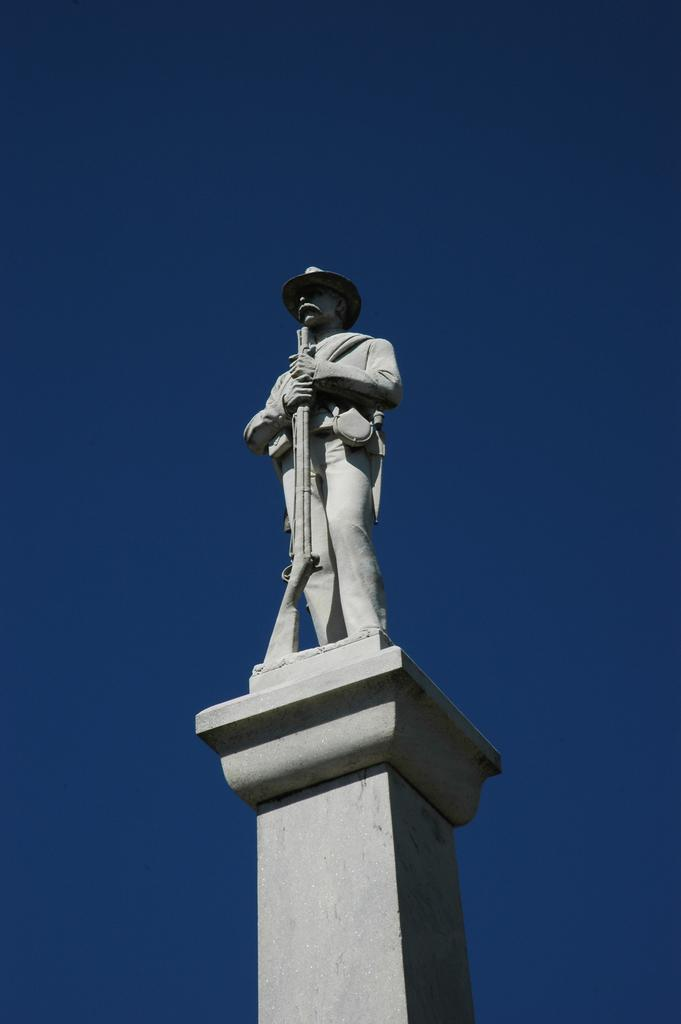What is the main subject of the image? There is a statue of a person in the image. Where is the statue located? The statue is on a platform. What can be seen in the background of the image? The sky is visible in the background of the image. How many oranges are hanging from the statue's arms in the image? There are no oranges present in the image; the statue is of a person. Is there a nest built around the statue in the image? There is no nest present in the image; the statue is on a platform with the sky visible in the background. 